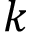<formula> <loc_0><loc_0><loc_500><loc_500>k</formula> 